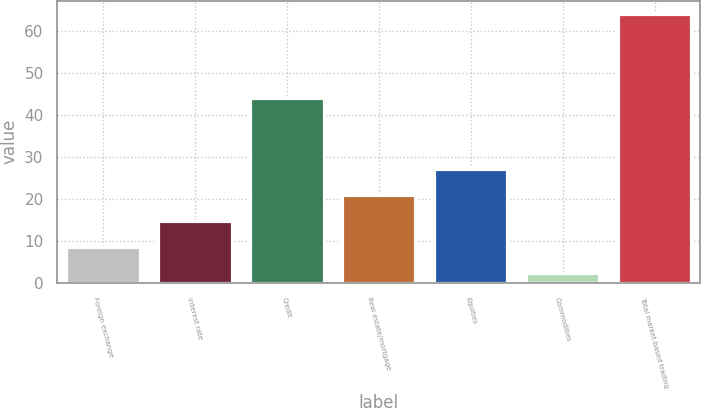Convert chart. <chart><loc_0><loc_0><loc_500><loc_500><bar_chart><fcel>Foreign exchange<fcel>Interest rate<fcel>Credit<fcel>Real estate/mortgage<fcel>Equities<fcel>Commodities<fcel>Total market-based trading<nl><fcel>8.57<fcel>14.74<fcel>44.1<fcel>20.91<fcel>27.08<fcel>2.4<fcel>64.1<nl></chart> 